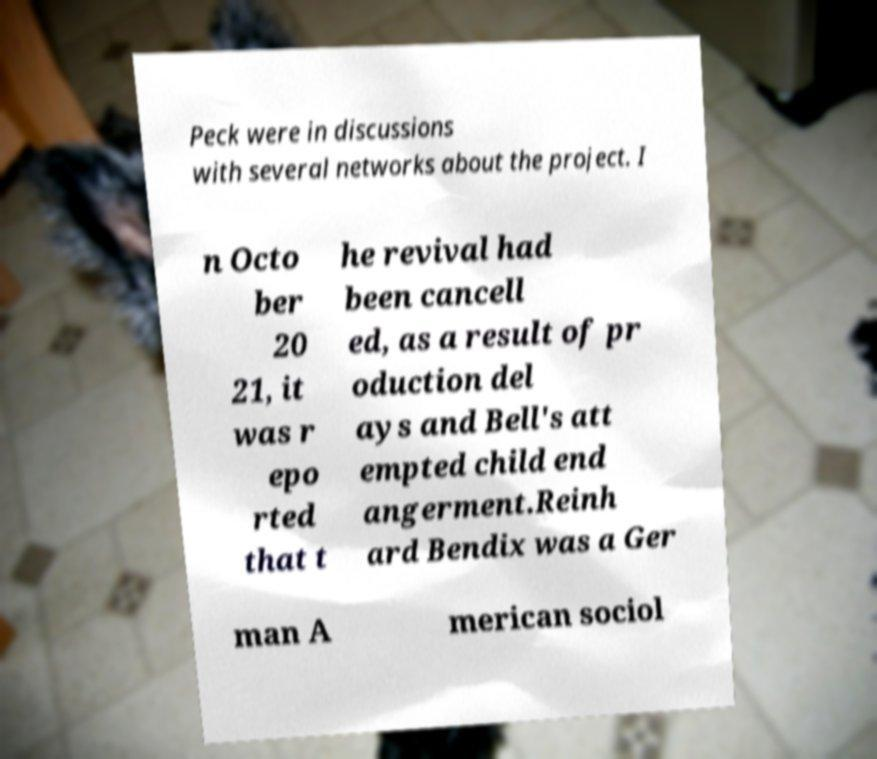Can you read and provide the text displayed in the image?This photo seems to have some interesting text. Can you extract and type it out for me? Peck were in discussions with several networks about the project. I n Octo ber 20 21, it was r epo rted that t he revival had been cancell ed, as a result of pr oduction del ays and Bell's att empted child end angerment.Reinh ard Bendix was a Ger man A merican sociol 